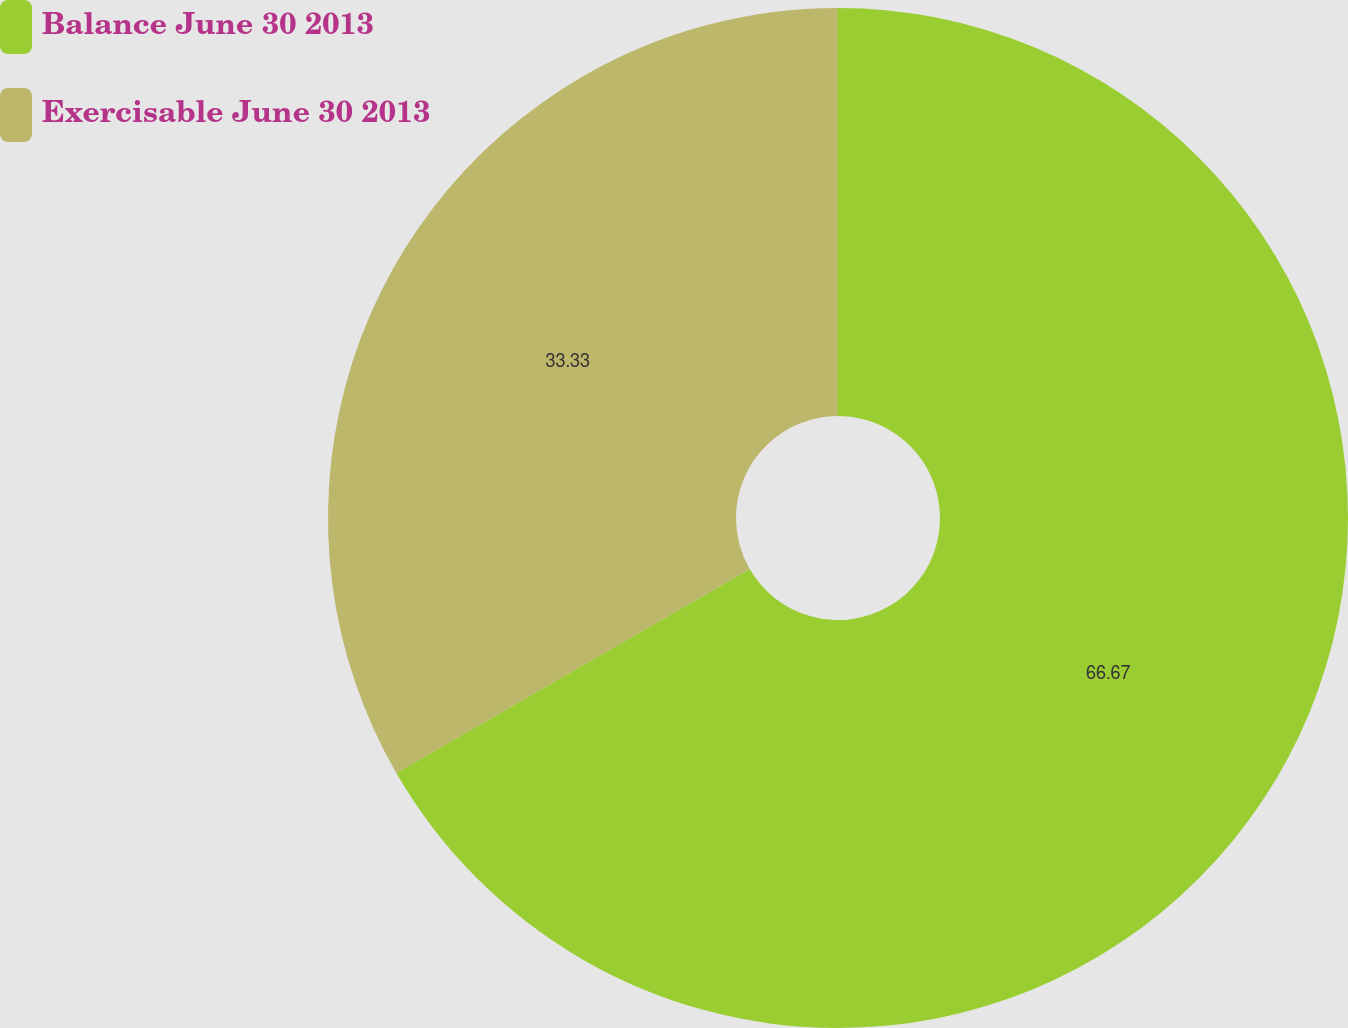Convert chart to OTSL. <chart><loc_0><loc_0><loc_500><loc_500><pie_chart><fcel>Balance June 30 2013<fcel>Exercisable June 30 2013<nl><fcel>66.67%<fcel>33.33%<nl></chart> 